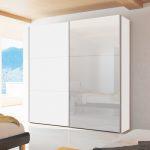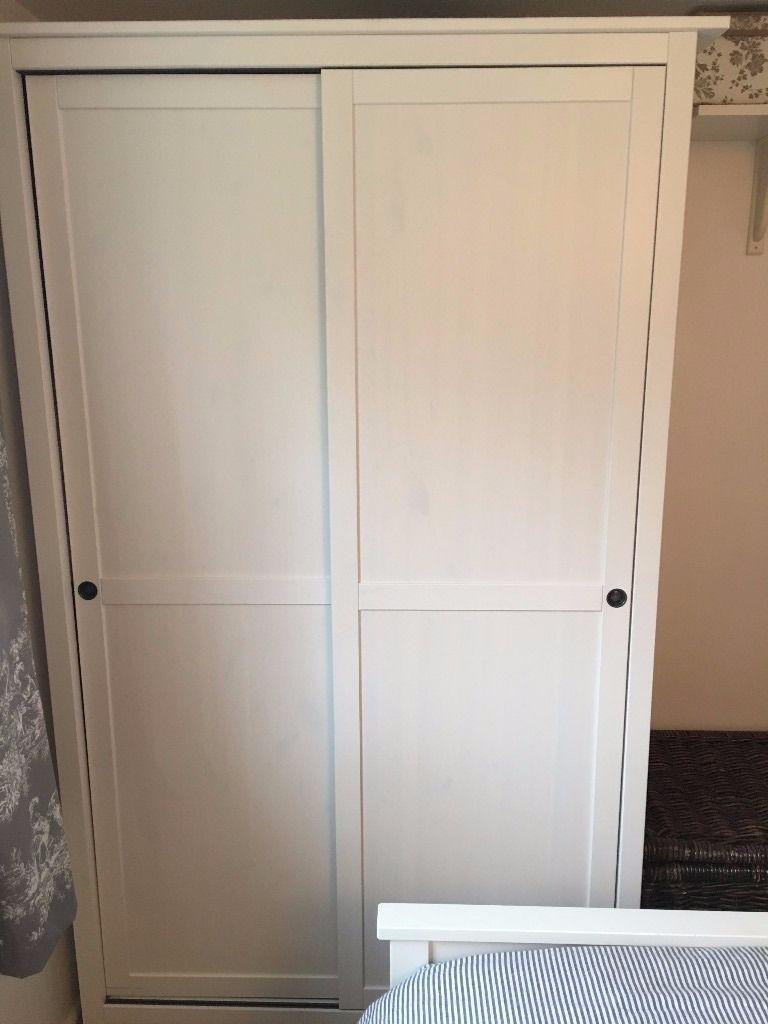The first image is the image on the left, the second image is the image on the right. Given the left and right images, does the statement "There is a chair in the image on the right." hold true? Answer yes or no. No. The first image is the image on the left, the second image is the image on the right. Analyze the images presented: Is the assertion "There are two closets with glass doors." valid? Answer yes or no. No. 